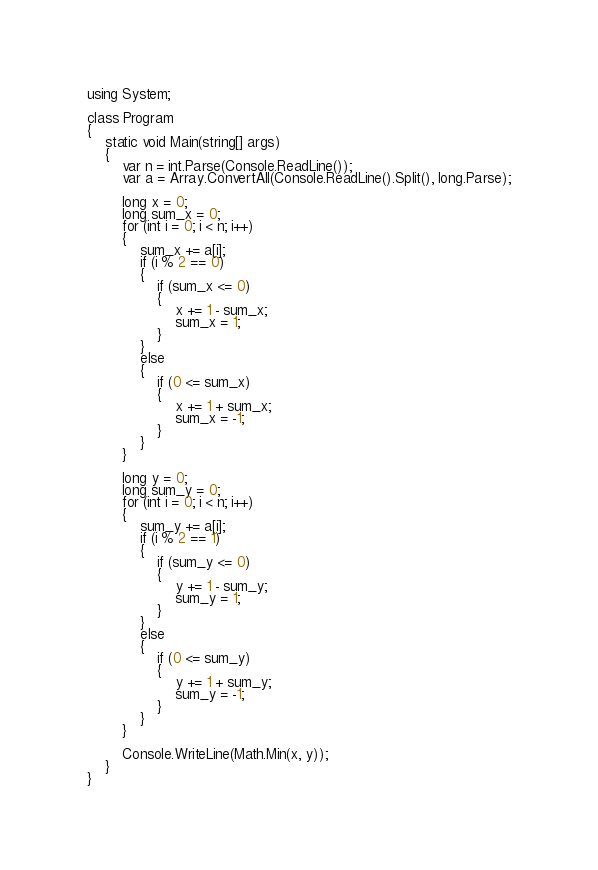<code> <loc_0><loc_0><loc_500><loc_500><_C#_>using System;

class Program
{
    static void Main(string[] args)
    {
        var n = int.Parse(Console.ReadLine());
        var a = Array.ConvertAll(Console.ReadLine().Split(), long.Parse);

        long x = 0;
        long sum_x = 0;
        for (int i = 0; i < n; i++)
        {
            sum_x += a[i];
            if (i % 2 == 0)
            {
                if (sum_x <= 0)
                {
                    x += 1 - sum_x;
                    sum_x = 1;
                }
            }
            else
            {
                if (0 <= sum_x)
                {
                    x += 1 + sum_x;
                    sum_x = -1;
                }
            }
        }

        long y = 0;
        long sum_y = 0;
        for (int i = 0; i < n; i++)
        {
            sum_y += a[i];
            if (i % 2 == 1)
            {
                if (sum_y <= 0)
                {
                    y += 1 - sum_y;
                    sum_y = 1;
                }
            }
            else
            {
                if (0 <= sum_y)
                {
                    y += 1 + sum_y;
                    sum_y = -1;
                }
            }
        }

        Console.WriteLine(Math.Min(x, y));
    }
}
</code> 